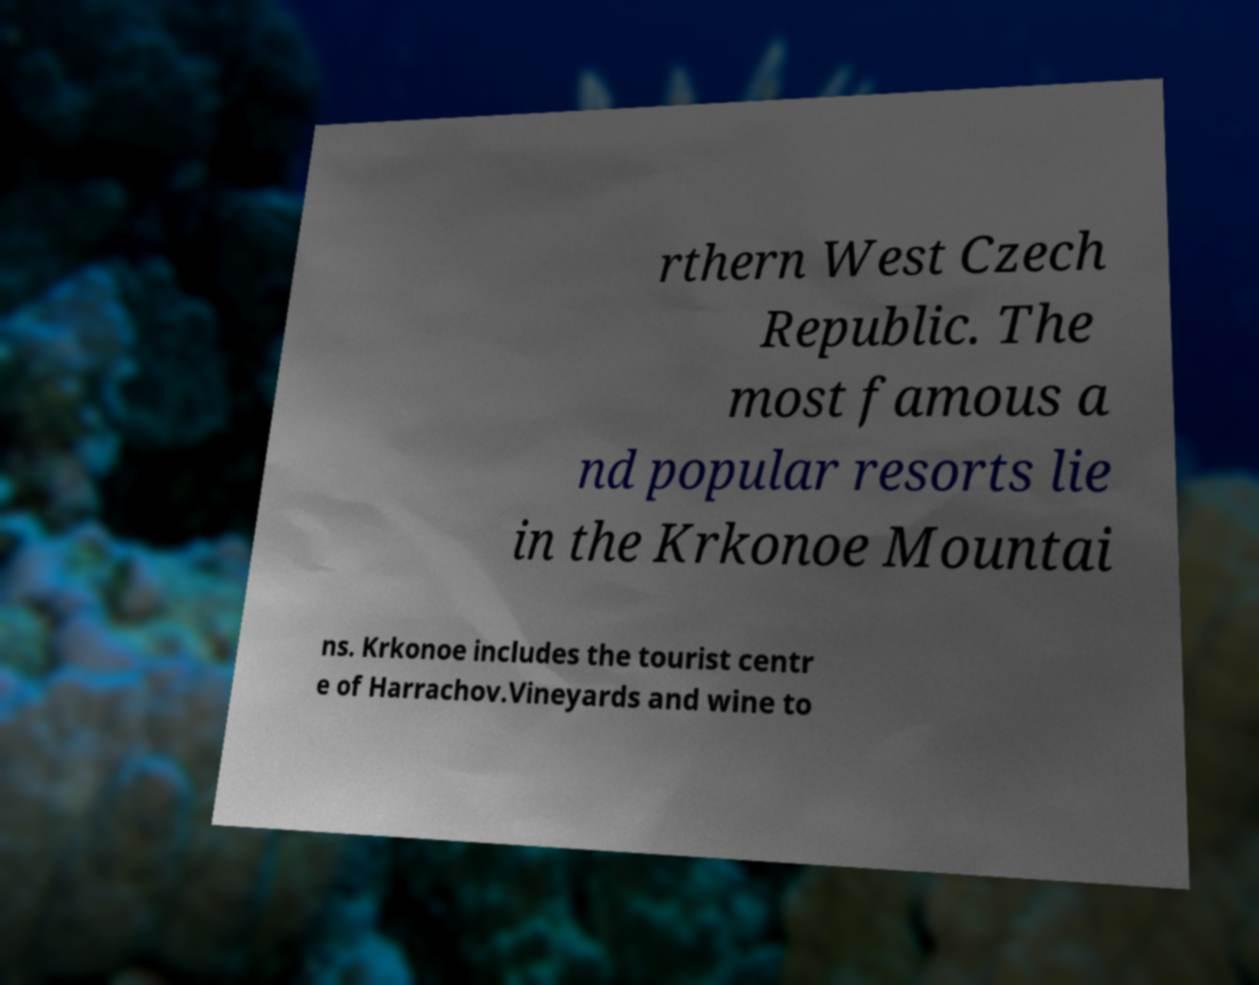What messages or text are displayed in this image? I need them in a readable, typed format. rthern West Czech Republic. The most famous a nd popular resorts lie in the Krkonoe Mountai ns. Krkonoe includes the tourist centr e of Harrachov.Vineyards and wine to 